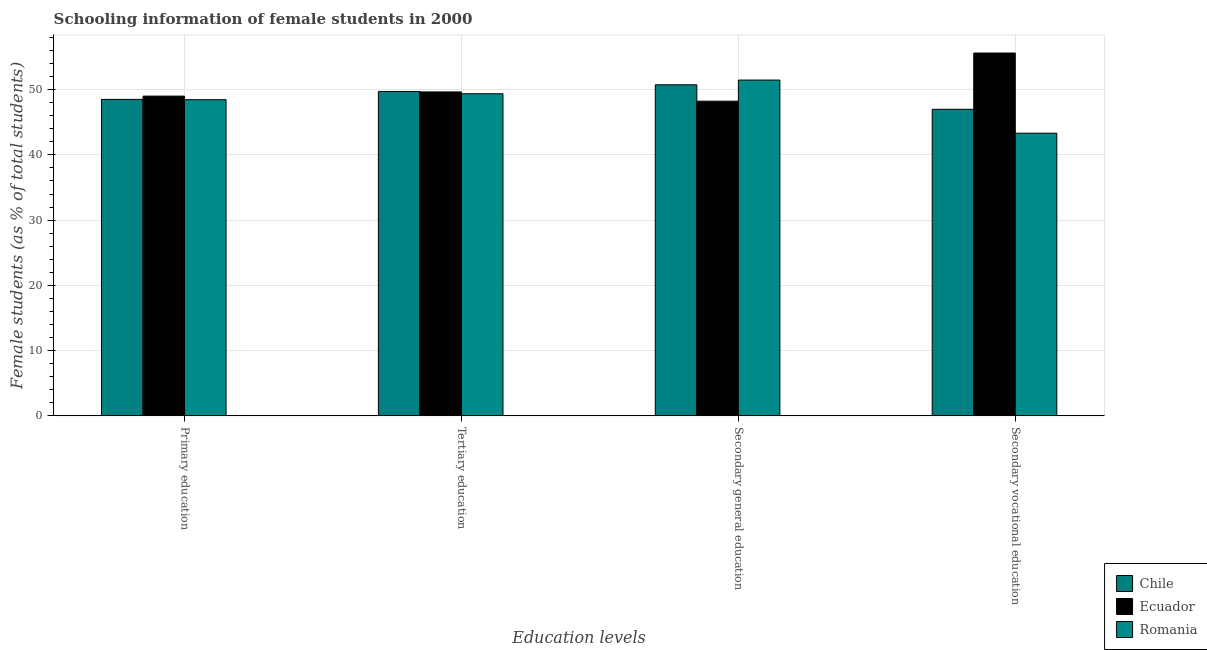How many groups of bars are there?
Your answer should be very brief. 4. Are the number of bars on each tick of the X-axis equal?
Keep it short and to the point. Yes. How many bars are there on the 1st tick from the left?
Offer a terse response. 3. How many bars are there on the 4th tick from the right?
Provide a succinct answer. 3. What is the percentage of female students in secondary vocational education in Romania?
Provide a short and direct response. 43.33. Across all countries, what is the maximum percentage of female students in secondary education?
Your answer should be compact. 51.47. Across all countries, what is the minimum percentage of female students in secondary vocational education?
Keep it short and to the point. 43.33. In which country was the percentage of female students in secondary education maximum?
Offer a very short reply. Romania. In which country was the percentage of female students in secondary vocational education minimum?
Your response must be concise. Romania. What is the total percentage of female students in secondary education in the graph?
Provide a short and direct response. 150.44. What is the difference between the percentage of female students in secondary vocational education in Chile and that in Romania?
Provide a succinct answer. 3.66. What is the difference between the percentage of female students in primary education in Romania and the percentage of female students in secondary education in Ecuador?
Provide a short and direct response. 0.23. What is the average percentage of female students in primary education per country?
Your answer should be compact. 48.66. What is the difference between the percentage of female students in secondary education and percentage of female students in primary education in Romania?
Give a very brief answer. 3.01. What is the ratio of the percentage of female students in tertiary education in Ecuador to that in Romania?
Your answer should be compact. 1.01. Is the difference between the percentage of female students in secondary vocational education in Chile and Romania greater than the difference between the percentage of female students in tertiary education in Chile and Romania?
Your answer should be compact. Yes. What is the difference between the highest and the second highest percentage of female students in secondary vocational education?
Ensure brevity in your answer.  8.62. What is the difference between the highest and the lowest percentage of female students in secondary education?
Your answer should be compact. 3.24. Is it the case that in every country, the sum of the percentage of female students in secondary education and percentage of female students in secondary vocational education is greater than the sum of percentage of female students in primary education and percentage of female students in tertiary education?
Your answer should be compact. No. What does the 2nd bar from the left in Secondary vocational education represents?
Make the answer very short. Ecuador. What does the 1st bar from the right in Secondary vocational education represents?
Your answer should be compact. Romania. Is it the case that in every country, the sum of the percentage of female students in primary education and percentage of female students in tertiary education is greater than the percentage of female students in secondary education?
Your answer should be compact. Yes. How many bars are there?
Give a very brief answer. 12. What is the difference between two consecutive major ticks on the Y-axis?
Ensure brevity in your answer.  10. Does the graph contain any zero values?
Provide a short and direct response. No. Does the graph contain grids?
Give a very brief answer. Yes. Where does the legend appear in the graph?
Keep it short and to the point. Bottom right. What is the title of the graph?
Make the answer very short. Schooling information of female students in 2000. What is the label or title of the X-axis?
Make the answer very short. Education levels. What is the label or title of the Y-axis?
Offer a very short reply. Female students (as % of total students). What is the Female students (as % of total students) of Chile in Primary education?
Give a very brief answer. 48.51. What is the Female students (as % of total students) in Ecuador in Primary education?
Provide a succinct answer. 49.01. What is the Female students (as % of total students) in Romania in Primary education?
Provide a succinct answer. 48.46. What is the Female students (as % of total students) in Chile in Tertiary education?
Offer a very short reply. 49.72. What is the Female students (as % of total students) in Ecuador in Tertiary education?
Ensure brevity in your answer.  49.65. What is the Female students (as % of total students) of Romania in Tertiary education?
Ensure brevity in your answer.  49.37. What is the Female students (as % of total students) in Chile in Secondary general education?
Ensure brevity in your answer.  50.74. What is the Female students (as % of total students) of Ecuador in Secondary general education?
Give a very brief answer. 48.23. What is the Female students (as % of total students) of Romania in Secondary general education?
Your answer should be compact. 51.47. What is the Female students (as % of total students) of Chile in Secondary vocational education?
Offer a terse response. 46.99. What is the Female students (as % of total students) in Ecuador in Secondary vocational education?
Ensure brevity in your answer.  55.62. What is the Female students (as % of total students) in Romania in Secondary vocational education?
Provide a short and direct response. 43.33. Across all Education levels, what is the maximum Female students (as % of total students) of Chile?
Make the answer very short. 50.74. Across all Education levels, what is the maximum Female students (as % of total students) in Ecuador?
Provide a succinct answer. 55.62. Across all Education levels, what is the maximum Female students (as % of total students) of Romania?
Your answer should be compact. 51.47. Across all Education levels, what is the minimum Female students (as % of total students) of Chile?
Provide a short and direct response. 46.99. Across all Education levels, what is the minimum Female students (as % of total students) in Ecuador?
Make the answer very short. 48.23. Across all Education levels, what is the minimum Female students (as % of total students) in Romania?
Keep it short and to the point. 43.33. What is the total Female students (as % of total students) in Chile in the graph?
Provide a succinct answer. 195.97. What is the total Female students (as % of total students) in Ecuador in the graph?
Your answer should be compact. 202.51. What is the total Female students (as % of total students) in Romania in the graph?
Ensure brevity in your answer.  192.63. What is the difference between the Female students (as % of total students) in Chile in Primary education and that in Tertiary education?
Make the answer very short. -1.22. What is the difference between the Female students (as % of total students) in Ecuador in Primary education and that in Tertiary education?
Your response must be concise. -0.64. What is the difference between the Female students (as % of total students) in Romania in Primary education and that in Tertiary education?
Provide a succinct answer. -0.91. What is the difference between the Female students (as % of total students) in Chile in Primary education and that in Secondary general education?
Provide a short and direct response. -2.23. What is the difference between the Female students (as % of total students) in Ecuador in Primary education and that in Secondary general education?
Offer a terse response. 0.78. What is the difference between the Female students (as % of total students) of Romania in Primary education and that in Secondary general education?
Your response must be concise. -3.01. What is the difference between the Female students (as % of total students) in Chile in Primary education and that in Secondary vocational education?
Offer a very short reply. 1.52. What is the difference between the Female students (as % of total students) of Ecuador in Primary education and that in Secondary vocational education?
Your answer should be compact. -6.61. What is the difference between the Female students (as % of total students) of Romania in Primary education and that in Secondary vocational education?
Provide a short and direct response. 5.13. What is the difference between the Female students (as % of total students) of Chile in Tertiary education and that in Secondary general education?
Offer a terse response. -1.02. What is the difference between the Female students (as % of total students) of Ecuador in Tertiary education and that in Secondary general education?
Make the answer very short. 1.42. What is the difference between the Female students (as % of total students) of Romania in Tertiary education and that in Secondary general education?
Make the answer very short. -2.1. What is the difference between the Female students (as % of total students) in Chile in Tertiary education and that in Secondary vocational education?
Provide a short and direct response. 2.73. What is the difference between the Female students (as % of total students) of Ecuador in Tertiary education and that in Secondary vocational education?
Your answer should be very brief. -5.96. What is the difference between the Female students (as % of total students) of Romania in Tertiary education and that in Secondary vocational education?
Offer a terse response. 6.04. What is the difference between the Female students (as % of total students) in Chile in Secondary general education and that in Secondary vocational education?
Provide a succinct answer. 3.75. What is the difference between the Female students (as % of total students) in Ecuador in Secondary general education and that in Secondary vocational education?
Offer a terse response. -7.38. What is the difference between the Female students (as % of total students) in Romania in Secondary general education and that in Secondary vocational education?
Give a very brief answer. 8.14. What is the difference between the Female students (as % of total students) in Chile in Primary education and the Female students (as % of total students) in Ecuador in Tertiary education?
Provide a succinct answer. -1.14. What is the difference between the Female students (as % of total students) of Chile in Primary education and the Female students (as % of total students) of Romania in Tertiary education?
Make the answer very short. -0.86. What is the difference between the Female students (as % of total students) of Ecuador in Primary education and the Female students (as % of total students) of Romania in Tertiary education?
Your response must be concise. -0.36. What is the difference between the Female students (as % of total students) of Chile in Primary education and the Female students (as % of total students) of Ecuador in Secondary general education?
Your response must be concise. 0.28. What is the difference between the Female students (as % of total students) of Chile in Primary education and the Female students (as % of total students) of Romania in Secondary general education?
Give a very brief answer. -2.96. What is the difference between the Female students (as % of total students) in Ecuador in Primary education and the Female students (as % of total students) in Romania in Secondary general education?
Your response must be concise. -2.46. What is the difference between the Female students (as % of total students) of Chile in Primary education and the Female students (as % of total students) of Ecuador in Secondary vocational education?
Provide a short and direct response. -7.11. What is the difference between the Female students (as % of total students) of Chile in Primary education and the Female students (as % of total students) of Romania in Secondary vocational education?
Provide a short and direct response. 5.18. What is the difference between the Female students (as % of total students) of Ecuador in Primary education and the Female students (as % of total students) of Romania in Secondary vocational education?
Offer a very short reply. 5.68. What is the difference between the Female students (as % of total students) in Chile in Tertiary education and the Female students (as % of total students) in Ecuador in Secondary general education?
Your answer should be compact. 1.49. What is the difference between the Female students (as % of total students) in Chile in Tertiary education and the Female students (as % of total students) in Romania in Secondary general education?
Provide a succinct answer. -1.75. What is the difference between the Female students (as % of total students) of Ecuador in Tertiary education and the Female students (as % of total students) of Romania in Secondary general education?
Provide a succinct answer. -1.82. What is the difference between the Female students (as % of total students) in Chile in Tertiary education and the Female students (as % of total students) in Ecuador in Secondary vocational education?
Provide a succinct answer. -5.89. What is the difference between the Female students (as % of total students) of Chile in Tertiary education and the Female students (as % of total students) of Romania in Secondary vocational education?
Your answer should be very brief. 6.39. What is the difference between the Female students (as % of total students) in Ecuador in Tertiary education and the Female students (as % of total students) in Romania in Secondary vocational education?
Offer a terse response. 6.32. What is the difference between the Female students (as % of total students) of Chile in Secondary general education and the Female students (as % of total students) of Ecuador in Secondary vocational education?
Give a very brief answer. -4.87. What is the difference between the Female students (as % of total students) in Chile in Secondary general education and the Female students (as % of total students) in Romania in Secondary vocational education?
Make the answer very short. 7.41. What is the difference between the Female students (as % of total students) of Ecuador in Secondary general education and the Female students (as % of total students) of Romania in Secondary vocational education?
Keep it short and to the point. 4.9. What is the average Female students (as % of total students) in Chile per Education levels?
Ensure brevity in your answer.  48.99. What is the average Female students (as % of total students) in Ecuador per Education levels?
Offer a terse response. 50.63. What is the average Female students (as % of total students) in Romania per Education levels?
Keep it short and to the point. 48.16. What is the difference between the Female students (as % of total students) of Chile and Female students (as % of total students) of Romania in Primary education?
Offer a very short reply. 0.05. What is the difference between the Female students (as % of total students) in Ecuador and Female students (as % of total students) in Romania in Primary education?
Your answer should be very brief. 0.55. What is the difference between the Female students (as % of total students) in Chile and Female students (as % of total students) in Ecuador in Tertiary education?
Keep it short and to the point. 0.07. What is the difference between the Female students (as % of total students) in Chile and Female students (as % of total students) in Romania in Tertiary education?
Provide a succinct answer. 0.35. What is the difference between the Female students (as % of total students) of Ecuador and Female students (as % of total students) of Romania in Tertiary education?
Keep it short and to the point. 0.28. What is the difference between the Female students (as % of total students) of Chile and Female students (as % of total students) of Ecuador in Secondary general education?
Offer a very short reply. 2.51. What is the difference between the Female students (as % of total students) in Chile and Female students (as % of total students) in Romania in Secondary general education?
Provide a succinct answer. -0.73. What is the difference between the Female students (as % of total students) in Ecuador and Female students (as % of total students) in Romania in Secondary general education?
Offer a terse response. -3.24. What is the difference between the Female students (as % of total students) in Chile and Female students (as % of total students) in Ecuador in Secondary vocational education?
Provide a succinct answer. -8.62. What is the difference between the Female students (as % of total students) of Chile and Female students (as % of total students) of Romania in Secondary vocational education?
Offer a terse response. 3.66. What is the difference between the Female students (as % of total students) in Ecuador and Female students (as % of total students) in Romania in Secondary vocational education?
Make the answer very short. 12.29. What is the ratio of the Female students (as % of total students) of Chile in Primary education to that in Tertiary education?
Provide a short and direct response. 0.98. What is the ratio of the Female students (as % of total students) in Ecuador in Primary education to that in Tertiary education?
Offer a terse response. 0.99. What is the ratio of the Female students (as % of total students) of Romania in Primary education to that in Tertiary education?
Your answer should be compact. 0.98. What is the ratio of the Female students (as % of total students) in Chile in Primary education to that in Secondary general education?
Make the answer very short. 0.96. What is the ratio of the Female students (as % of total students) of Ecuador in Primary education to that in Secondary general education?
Ensure brevity in your answer.  1.02. What is the ratio of the Female students (as % of total students) in Romania in Primary education to that in Secondary general education?
Keep it short and to the point. 0.94. What is the ratio of the Female students (as % of total students) in Chile in Primary education to that in Secondary vocational education?
Ensure brevity in your answer.  1.03. What is the ratio of the Female students (as % of total students) in Ecuador in Primary education to that in Secondary vocational education?
Provide a short and direct response. 0.88. What is the ratio of the Female students (as % of total students) of Romania in Primary education to that in Secondary vocational education?
Your answer should be compact. 1.12. What is the ratio of the Female students (as % of total students) of Chile in Tertiary education to that in Secondary general education?
Make the answer very short. 0.98. What is the ratio of the Female students (as % of total students) of Ecuador in Tertiary education to that in Secondary general education?
Your answer should be very brief. 1.03. What is the ratio of the Female students (as % of total students) of Romania in Tertiary education to that in Secondary general education?
Your answer should be very brief. 0.96. What is the ratio of the Female students (as % of total students) of Chile in Tertiary education to that in Secondary vocational education?
Offer a very short reply. 1.06. What is the ratio of the Female students (as % of total students) in Ecuador in Tertiary education to that in Secondary vocational education?
Keep it short and to the point. 0.89. What is the ratio of the Female students (as % of total students) of Romania in Tertiary education to that in Secondary vocational education?
Provide a short and direct response. 1.14. What is the ratio of the Female students (as % of total students) of Chile in Secondary general education to that in Secondary vocational education?
Your response must be concise. 1.08. What is the ratio of the Female students (as % of total students) of Ecuador in Secondary general education to that in Secondary vocational education?
Your response must be concise. 0.87. What is the ratio of the Female students (as % of total students) of Romania in Secondary general education to that in Secondary vocational education?
Offer a very short reply. 1.19. What is the difference between the highest and the second highest Female students (as % of total students) in Chile?
Your response must be concise. 1.02. What is the difference between the highest and the second highest Female students (as % of total students) of Ecuador?
Give a very brief answer. 5.96. What is the difference between the highest and the second highest Female students (as % of total students) of Romania?
Your response must be concise. 2.1. What is the difference between the highest and the lowest Female students (as % of total students) in Chile?
Provide a succinct answer. 3.75. What is the difference between the highest and the lowest Female students (as % of total students) of Ecuador?
Offer a terse response. 7.38. What is the difference between the highest and the lowest Female students (as % of total students) in Romania?
Give a very brief answer. 8.14. 